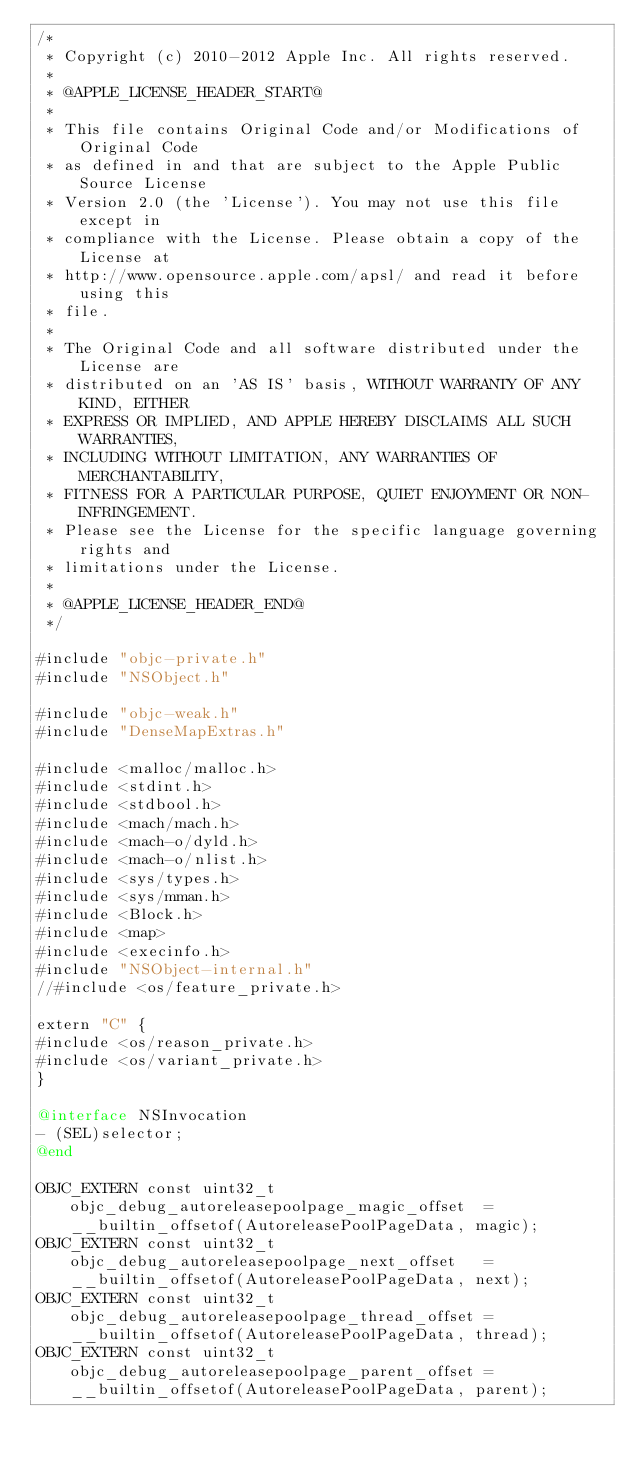Convert code to text. <code><loc_0><loc_0><loc_500><loc_500><_ObjectiveC_>/*
 * Copyright (c) 2010-2012 Apple Inc. All rights reserved.
 *
 * @APPLE_LICENSE_HEADER_START@
 *
 * This file contains Original Code and/or Modifications of Original Code
 * as defined in and that are subject to the Apple Public Source License
 * Version 2.0 (the 'License'). You may not use this file except in
 * compliance with the License. Please obtain a copy of the License at
 * http://www.opensource.apple.com/apsl/ and read it before using this
 * file.
 *
 * The Original Code and all software distributed under the License are
 * distributed on an 'AS IS' basis, WITHOUT WARRANTY OF ANY KIND, EITHER
 * EXPRESS OR IMPLIED, AND APPLE HEREBY DISCLAIMS ALL SUCH WARRANTIES,
 * INCLUDING WITHOUT LIMITATION, ANY WARRANTIES OF MERCHANTABILITY,
 * FITNESS FOR A PARTICULAR PURPOSE, QUIET ENJOYMENT OR NON-INFRINGEMENT.
 * Please see the License for the specific language governing rights and
 * limitations under the License.
 *
 * @APPLE_LICENSE_HEADER_END@
 */

#include "objc-private.h"
#include "NSObject.h"

#include "objc-weak.h"
#include "DenseMapExtras.h"

#include <malloc/malloc.h>
#include <stdint.h>
#include <stdbool.h>
#include <mach/mach.h>
#include <mach-o/dyld.h>
#include <mach-o/nlist.h>
#include <sys/types.h>
#include <sys/mman.h>
#include <Block.h>
#include <map>
#include <execinfo.h>
#include "NSObject-internal.h"
//#include <os/feature_private.h>

extern "C" {
#include <os/reason_private.h>
#include <os/variant_private.h>
}

@interface NSInvocation
- (SEL)selector;
@end

OBJC_EXTERN const uint32_t objc_debug_autoreleasepoolpage_magic_offset  = __builtin_offsetof(AutoreleasePoolPageData, magic);
OBJC_EXTERN const uint32_t objc_debug_autoreleasepoolpage_next_offset   = __builtin_offsetof(AutoreleasePoolPageData, next);
OBJC_EXTERN const uint32_t objc_debug_autoreleasepoolpage_thread_offset = __builtin_offsetof(AutoreleasePoolPageData, thread);
OBJC_EXTERN const uint32_t objc_debug_autoreleasepoolpage_parent_offset = __builtin_offsetof(AutoreleasePoolPageData, parent);</code> 